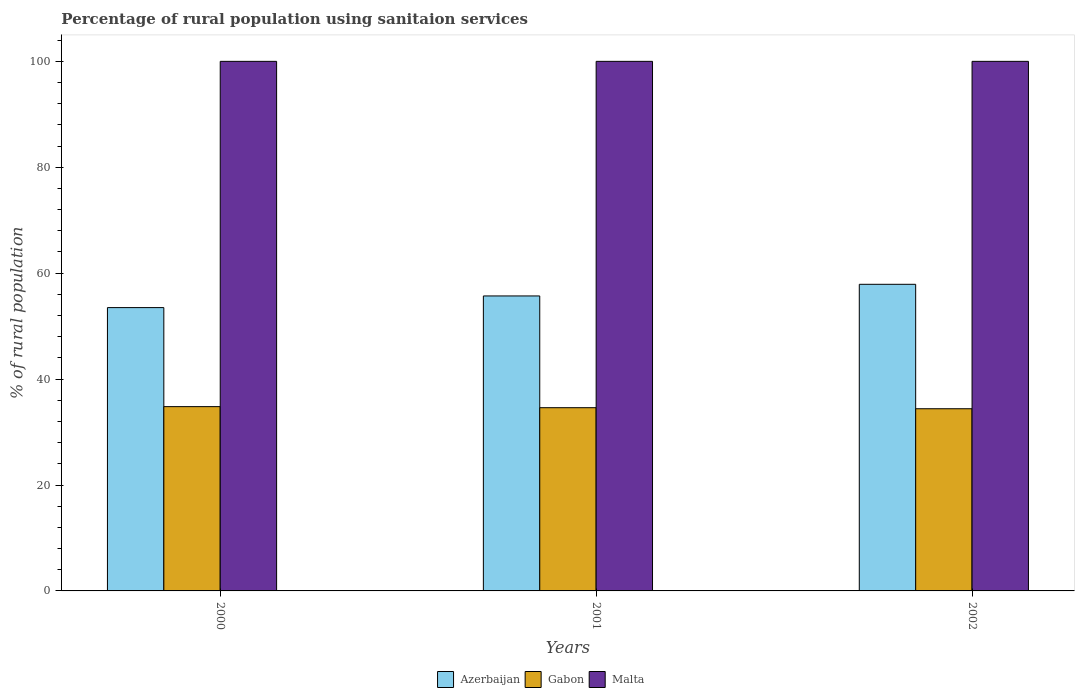How many different coloured bars are there?
Keep it short and to the point. 3. How many groups of bars are there?
Your answer should be compact. 3. Are the number of bars on each tick of the X-axis equal?
Ensure brevity in your answer.  Yes. How many bars are there on the 1st tick from the right?
Your response must be concise. 3. What is the label of the 2nd group of bars from the left?
Your answer should be compact. 2001. In how many cases, is the number of bars for a given year not equal to the number of legend labels?
Make the answer very short. 0. What is the percentage of rural population using sanitaion services in Azerbaijan in 2001?
Ensure brevity in your answer.  55.7. Across all years, what is the maximum percentage of rural population using sanitaion services in Azerbaijan?
Your answer should be very brief. 57.9. Across all years, what is the minimum percentage of rural population using sanitaion services in Gabon?
Offer a very short reply. 34.4. In which year was the percentage of rural population using sanitaion services in Gabon minimum?
Offer a terse response. 2002. What is the total percentage of rural population using sanitaion services in Gabon in the graph?
Your response must be concise. 103.8. What is the difference between the percentage of rural population using sanitaion services in Gabon in 2000 and that in 2002?
Offer a terse response. 0.4. What is the difference between the percentage of rural population using sanitaion services in Azerbaijan in 2001 and the percentage of rural population using sanitaion services in Malta in 2002?
Your response must be concise. -44.3. What is the average percentage of rural population using sanitaion services in Malta per year?
Ensure brevity in your answer.  100. In the year 2001, what is the difference between the percentage of rural population using sanitaion services in Azerbaijan and percentage of rural population using sanitaion services in Gabon?
Give a very brief answer. 21.1. In how many years, is the percentage of rural population using sanitaion services in Malta greater than 4 %?
Your answer should be compact. 3. What is the ratio of the percentage of rural population using sanitaion services in Gabon in 2000 to that in 2001?
Provide a succinct answer. 1.01. Is the percentage of rural population using sanitaion services in Gabon in 2000 less than that in 2002?
Ensure brevity in your answer.  No. What is the difference between the highest and the lowest percentage of rural population using sanitaion services in Malta?
Make the answer very short. 0. In how many years, is the percentage of rural population using sanitaion services in Azerbaijan greater than the average percentage of rural population using sanitaion services in Azerbaijan taken over all years?
Your response must be concise. 2. What does the 3rd bar from the left in 2002 represents?
Give a very brief answer. Malta. What does the 3rd bar from the right in 2002 represents?
Provide a short and direct response. Azerbaijan. How many years are there in the graph?
Ensure brevity in your answer.  3. What is the difference between two consecutive major ticks on the Y-axis?
Keep it short and to the point. 20. Are the values on the major ticks of Y-axis written in scientific E-notation?
Provide a short and direct response. No. Does the graph contain grids?
Your answer should be very brief. No. What is the title of the graph?
Offer a terse response. Percentage of rural population using sanitaion services. What is the label or title of the X-axis?
Provide a succinct answer. Years. What is the label or title of the Y-axis?
Offer a very short reply. % of rural population. What is the % of rural population of Azerbaijan in 2000?
Offer a very short reply. 53.5. What is the % of rural population of Gabon in 2000?
Offer a terse response. 34.8. What is the % of rural population of Azerbaijan in 2001?
Keep it short and to the point. 55.7. What is the % of rural population in Gabon in 2001?
Your answer should be compact. 34.6. What is the % of rural population of Azerbaijan in 2002?
Keep it short and to the point. 57.9. What is the % of rural population in Gabon in 2002?
Ensure brevity in your answer.  34.4. Across all years, what is the maximum % of rural population in Azerbaijan?
Your response must be concise. 57.9. Across all years, what is the maximum % of rural population in Gabon?
Provide a succinct answer. 34.8. Across all years, what is the minimum % of rural population in Azerbaijan?
Give a very brief answer. 53.5. Across all years, what is the minimum % of rural population of Gabon?
Give a very brief answer. 34.4. What is the total % of rural population of Azerbaijan in the graph?
Give a very brief answer. 167.1. What is the total % of rural population in Gabon in the graph?
Offer a very short reply. 103.8. What is the total % of rural population of Malta in the graph?
Your answer should be very brief. 300. What is the difference between the % of rural population in Malta in 2000 and that in 2001?
Provide a succinct answer. 0. What is the difference between the % of rural population in Gabon in 2000 and that in 2002?
Offer a terse response. 0.4. What is the difference between the % of rural population in Azerbaijan in 2000 and the % of rural population in Gabon in 2001?
Provide a short and direct response. 18.9. What is the difference between the % of rural population in Azerbaijan in 2000 and the % of rural population in Malta in 2001?
Keep it short and to the point. -46.5. What is the difference between the % of rural population of Gabon in 2000 and the % of rural population of Malta in 2001?
Your answer should be very brief. -65.2. What is the difference between the % of rural population in Azerbaijan in 2000 and the % of rural population in Malta in 2002?
Provide a short and direct response. -46.5. What is the difference between the % of rural population in Gabon in 2000 and the % of rural population in Malta in 2002?
Provide a short and direct response. -65.2. What is the difference between the % of rural population in Azerbaijan in 2001 and the % of rural population in Gabon in 2002?
Your answer should be compact. 21.3. What is the difference between the % of rural population of Azerbaijan in 2001 and the % of rural population of Malta in 2002?
Provide a succinct answer. -44.3. What is the difference between the % of rural population in Gabon in 2001 and the % of rural population in Malta in 2002?
Your answer should be compact. -65.4. What is the average % of rural population of Azerbaijan per year?
Provide a succinct answer. 55.7. What is the average % of rural population in Gabon per year?
Keep it short and to the point. 34.6. In the year 2000, what is the difference between the % of rural population of Azerbaijan and % of rural population of Malta?
Your response must be concise. -46.5. In the year 2000, what is the difference between the % of rural population in Gabon and % of rural population in Malta?
Your answer should be very brief. -65.2. In the year 2001, what is the difference between the % of rural population in Azerbaijan and % of rural population in Gabon?
Your response must be concise. 21.1. In the year 2001, what is the difference between the % of rural population in Azerbaijan and % of rural population in Malta?
Offer a terse response. -44.3. In the year 2001, what is the difference between the % of rural population in Gabon and % of rural population in Malta?
Provide a short and direct response. -65.4. In the year 2002, what is the difference between the % of rural population in Azerbaijan and % of rural population in Gabon?
Provide a succinct answer. 23.5. In the year 2002, what is the difference between the % of rural population of Azerbaijan and % of rural population of Malta?
Provide a short and direct response. -42.1. In the year 2002, what is the difference between the % of rural population in Gabon and % of rural population in Malta?
Provide a succinct answer. -65.6. What is the ratio of the % of rural population of Azerbaijan in 2000 to that in 2001?
Make the answer very short. 0.96. What is the ratio of the % of rural population in Gabon in 2000 to that in 2001?
Ensure brevity in your answer.  1.01. What is the ratio of the % of rural population in Malta in 2000 to that in 2001?
Keep it short and to the point. 1. What is the ratio of the % of rural population of Azerbaijan in 2000 to that in 2002?
Offer a very short reply. 0.92. What is the ratio of the % of rural population of Gabon in 2000 to that in 2002?
Your answer should be very brief. 1.01. What is the ratio of the % of rural population in Azerbaijan in 2001 to that in 2002?
Your answer should be compact. 0.96. What is the ratio of the % of rural population in Gabon in 2001 to that in 2002?
Your response must be concise. 1.01. What is the difference between the highest and the second highest % of rural population of Malta?
Provide a short and direct response. 0. What is the difference between the highest and the lowest % of rural population of Gabon?
Provide a succinct answer. 0.4. 